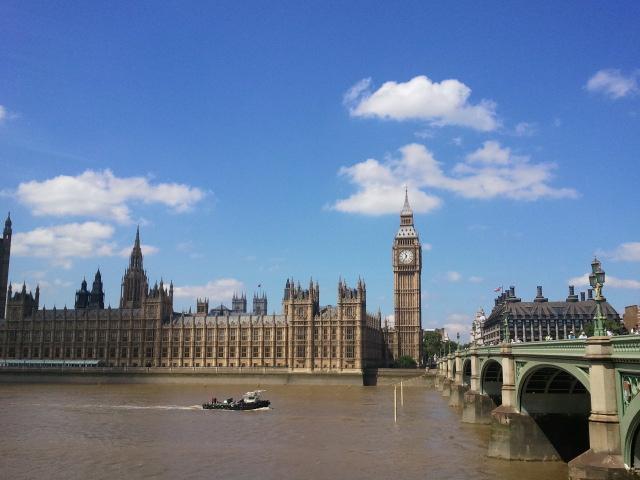What period of the day is shown in the image?
Select the correct answer and articulate reasoning with the following format: 'Answer: answer
Rationale: rationale.'
Options: Night, afternoon, evening, morning. Answer: morning.
Rationale: The period of time shown is morning daytime. 